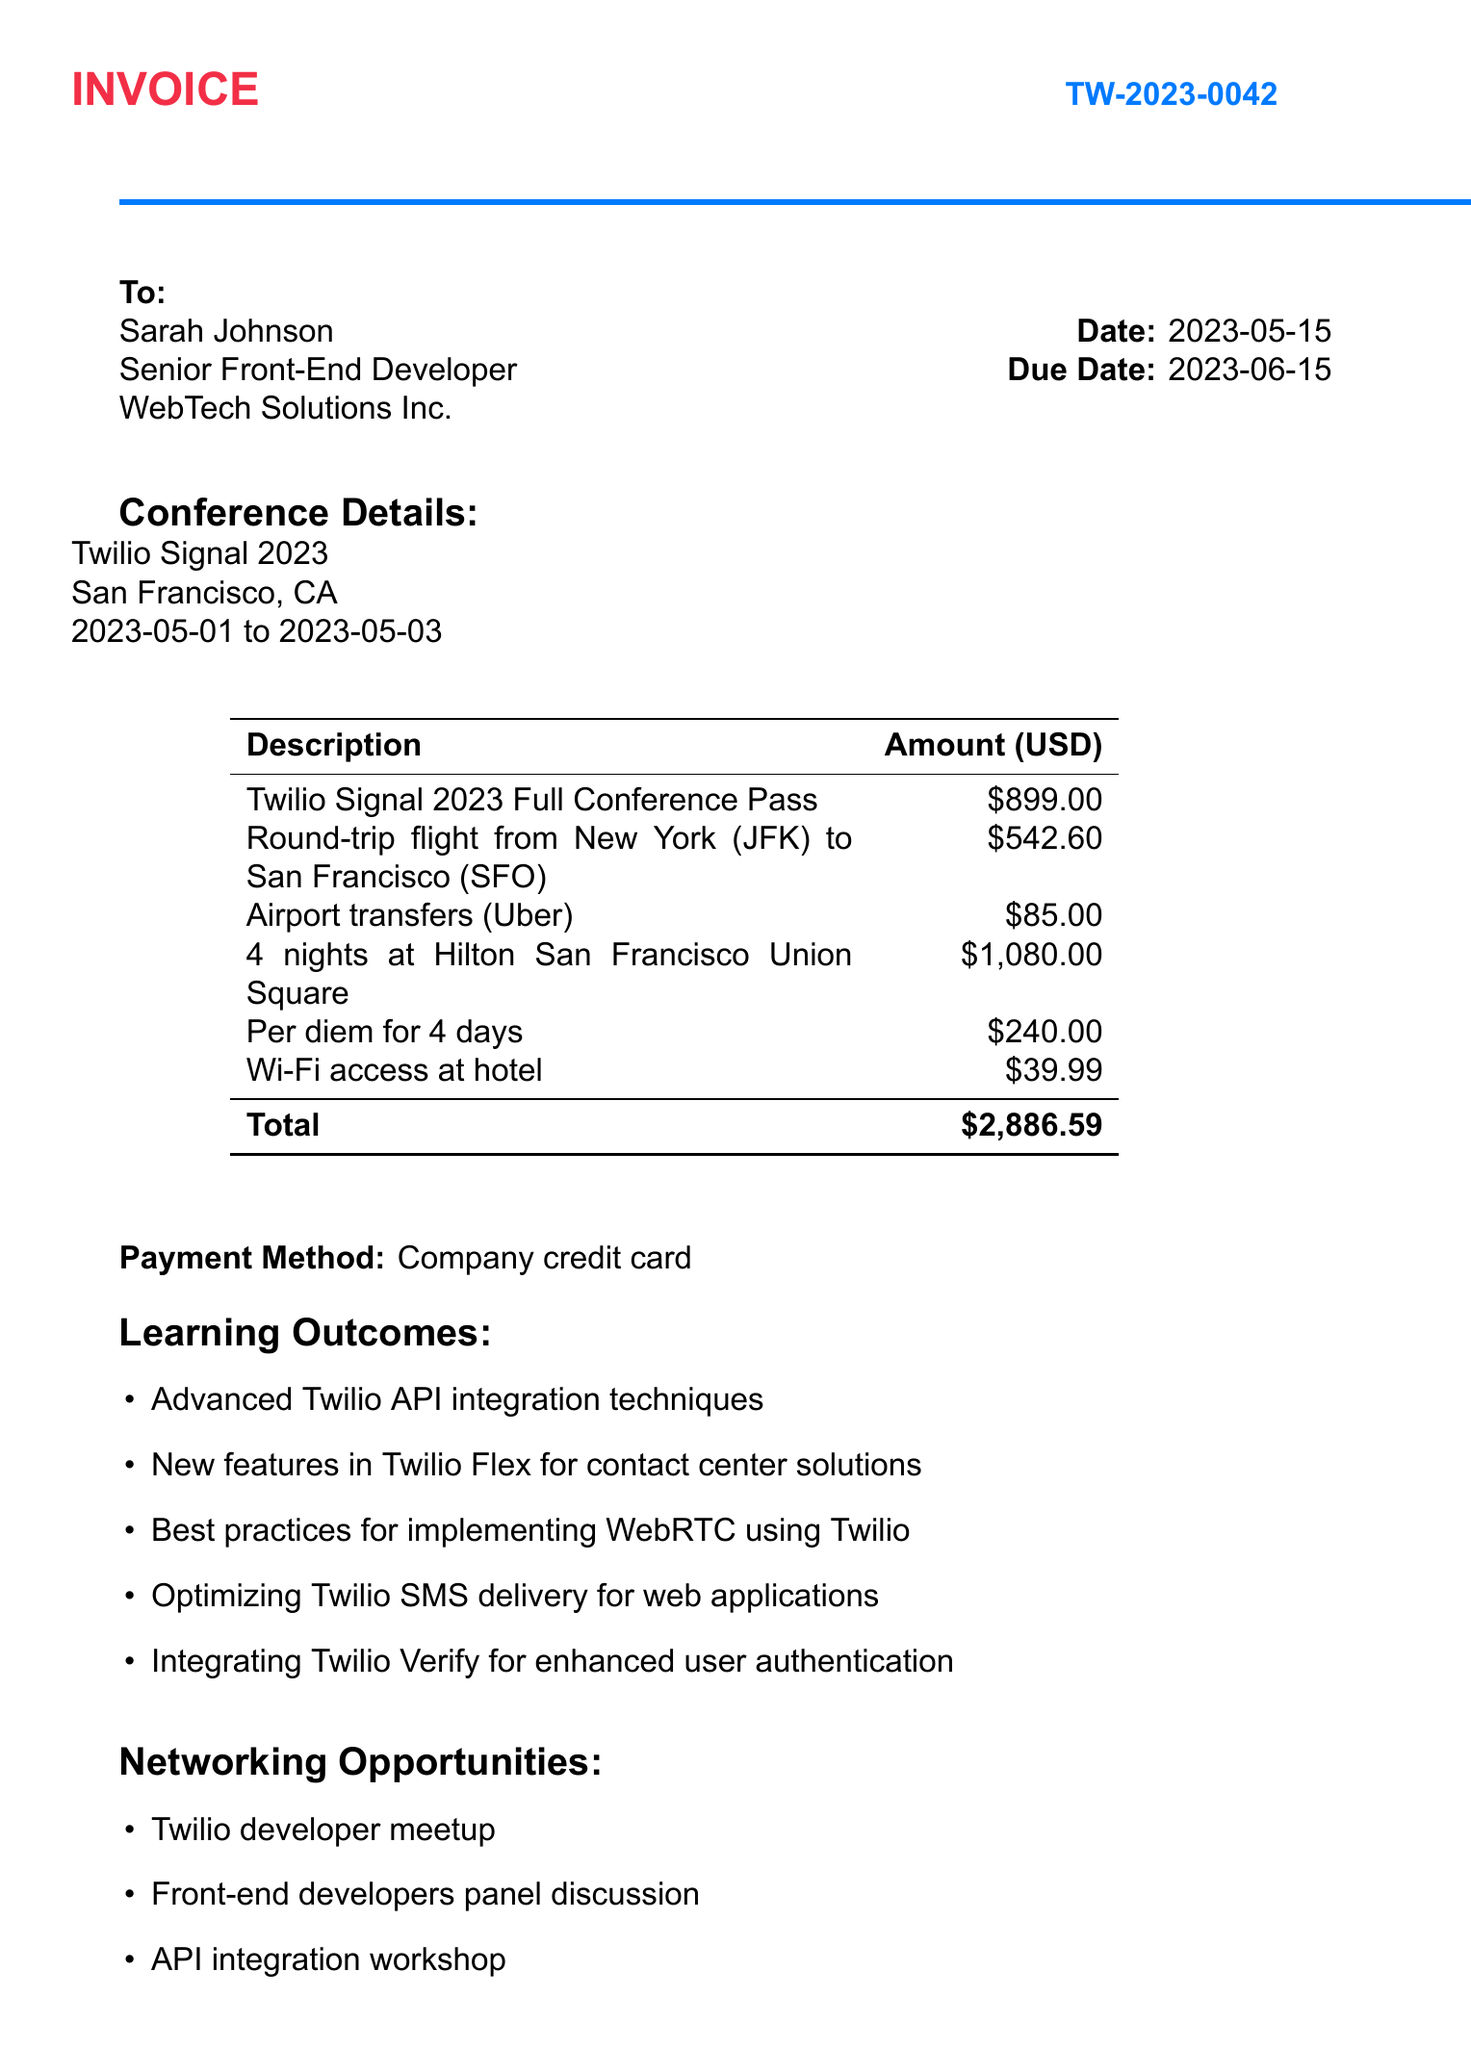What is the invoice number? The invoice number is listed in the document header under invoice details.
Answer: TW-2023-0042 When was the conference held? The dates of the conference can be found in the conference details section.
Answer: 2023-05-01 to 2023-05-03 What was the total amount of the expenses? The total amount is calculated as the sum of all expenses listed in the document.
Answer: $2,886.59 Who approved the invoice? The approver's name is found in the approval section of the document.
Answer: Michael Chen What category does the accommodation expense fall under? The accommodation is categorized in the expense list.
Answer: Accommodation How much was spent on travel expenses? Travel expenses are detailed in the expense section and need to be summed.
Answer: $627.60 What method was used to make the payment? The payment method is explicitly mentioned towards the end of the document.
Answer: Company credit card What learning outcome relates to user authentication? This requires identifying the specific learning outcome from the list provided.
Answer: Integrating Twilio Verify for enhanced user authentication How many nights was accommodation booked for? This can be derived from the description of the accommodation expense.
Answer: 4 nights 